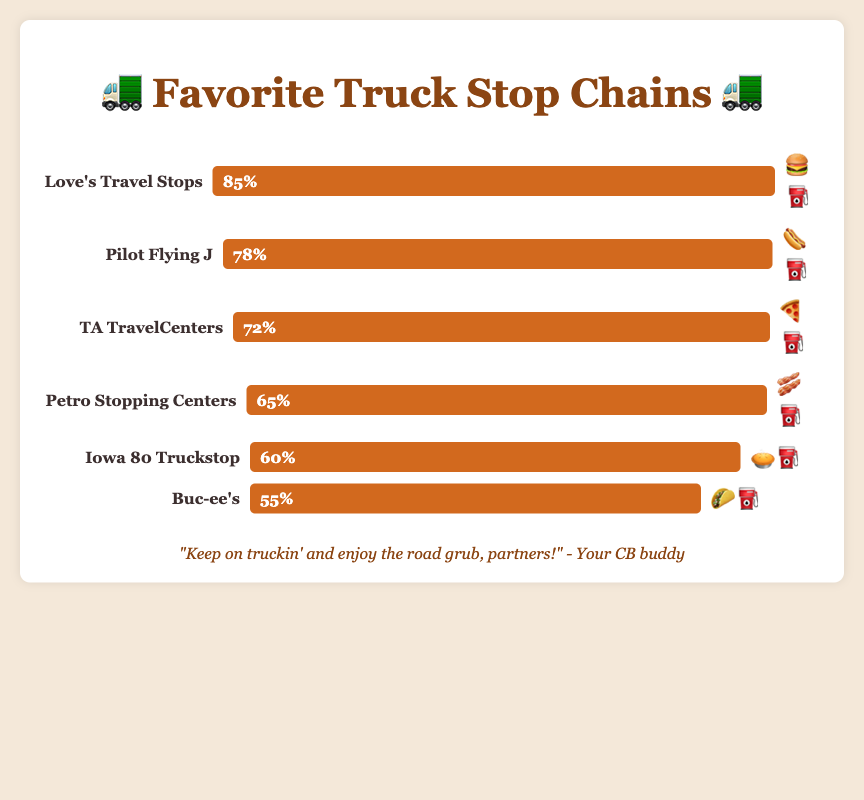What's the most popular truck stop chain? From the figure, the truck stop chain labeled with the highest percentage bar is "Love's Travel Stops" at 85%. The length of the bar and the percentage indicate its popularity.
Answer: Love's Travel Stops Which truck stop chain has a burger emoji? The emoji provided for each truck stop chain shows that "Love's Travel Stops" has a burger emoji.
Answer: Love's Travel Stops How much more popular is Love's Travel Stops compared to Buc-ee's? Love's Travel Stops has a popularity of 85%, and Buc-ee's has 55%. The difference between them is 85% - 55% = 30%.
Answer: 30% What’s the average popularity of all the listed truck stop chains? Adding all popularity values together: 85 + 78 + 72 + 65 + 60 + 55 = 415. There are 6 truck stops, so the average popularity is 415/6 ≈ 69.17%.
Answer: 69.17% Which truck stops have a gas pump emoji? Each of the truck stop chains in the figure has a gas pump emoji next to their name indicating they all have gas services.
Answer: All of them Rank the truck stop chains from least to most popular. From observing the bar lengths and percentage labels, the order from least to most popular is: Buc-ee's (55%), Iowa 80 Truckstop (60%), Petro Stopping Centers (65%), TA TravelCenters (72%), Pilot Flying J (78%), Love's Travel Stops (85%).
Answer: Buc-ee's, Iowa 80 Truckstop, Petro Stopping Centers, TA TravelCenters, Pilot Flying J, Love's Travel Stops What’s the combined popularity percentage of the three least popular truck stops? The three least popular truck stops are Buc-ee's (55%), Iowa 80 Truckstop (60%), and Petro Stopping Centers (65%). Combined popularity is 55% + 60% + 65% = 180%.
Answer: 180% Which two truck stops have a popularity difference of 7%? Calculating the differences between each adjacent truck stop chain, Pilot Flying J (78%) and TA TravelCenters (72%) have a difference of 78 - 72 = 6%, which is not 7%. Instead, Love's Travel Stops (85%) and Pilot Flying J (78%) give 85 - 78 = 7%.
Answer: Love's Travel Stops, Pilot Flying J Which truck stops are food-themed with a pie or taco emoji? Looking at the emojis, Iowa 80 Truckstop has a pie emoji (🥧⛽) and Buc-ee's has a taco emoji (🌮⛽).
Answer: Iowa 80 Truckstop, Buc-ee's 